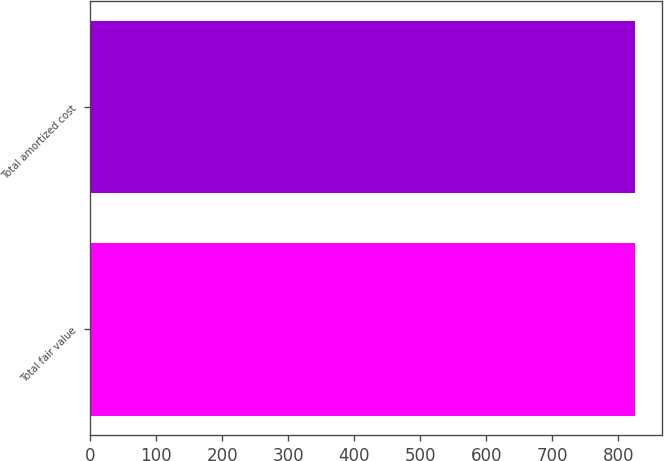<chart> <loc_0><loc_0><loc_500><loc_500><bar_chart><fcel>Total fair value<fcel>Total amortized cost<nl><fcel>825<fcel>825.1<nl></chart> 